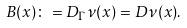<formula> <loc_0><loc_0><loc_500><loc_500>\ B ( x ) \colon = D _ { \Gamma } \nu ( x ) = D \nu ( x ) .</formula> 